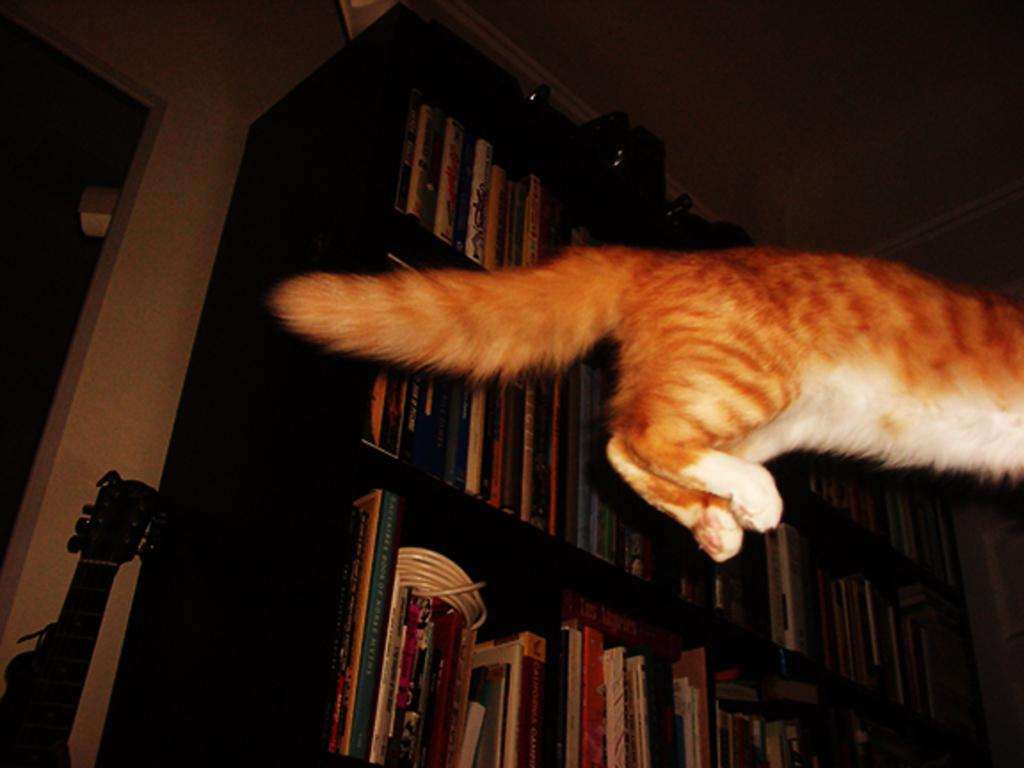What animal can be seen in the air on the right side of the image? There is a cat in the air on the right side of the image. What type of objects are visible in the background of the image? There are books in the background of the image. How are the books arranged in the image? The books are in bookshelves in the background of the image. What musical instrument can be seen leaning on the wall in the background of the image? There is a violin leaning on the wall in the background of the image. What type of powder is visible on the cat's paws in the image? There is no powder visible on the cat's paws in the image. What part of the violin is missing in the image? There is no indication that any part of the violin is missing in the image. 